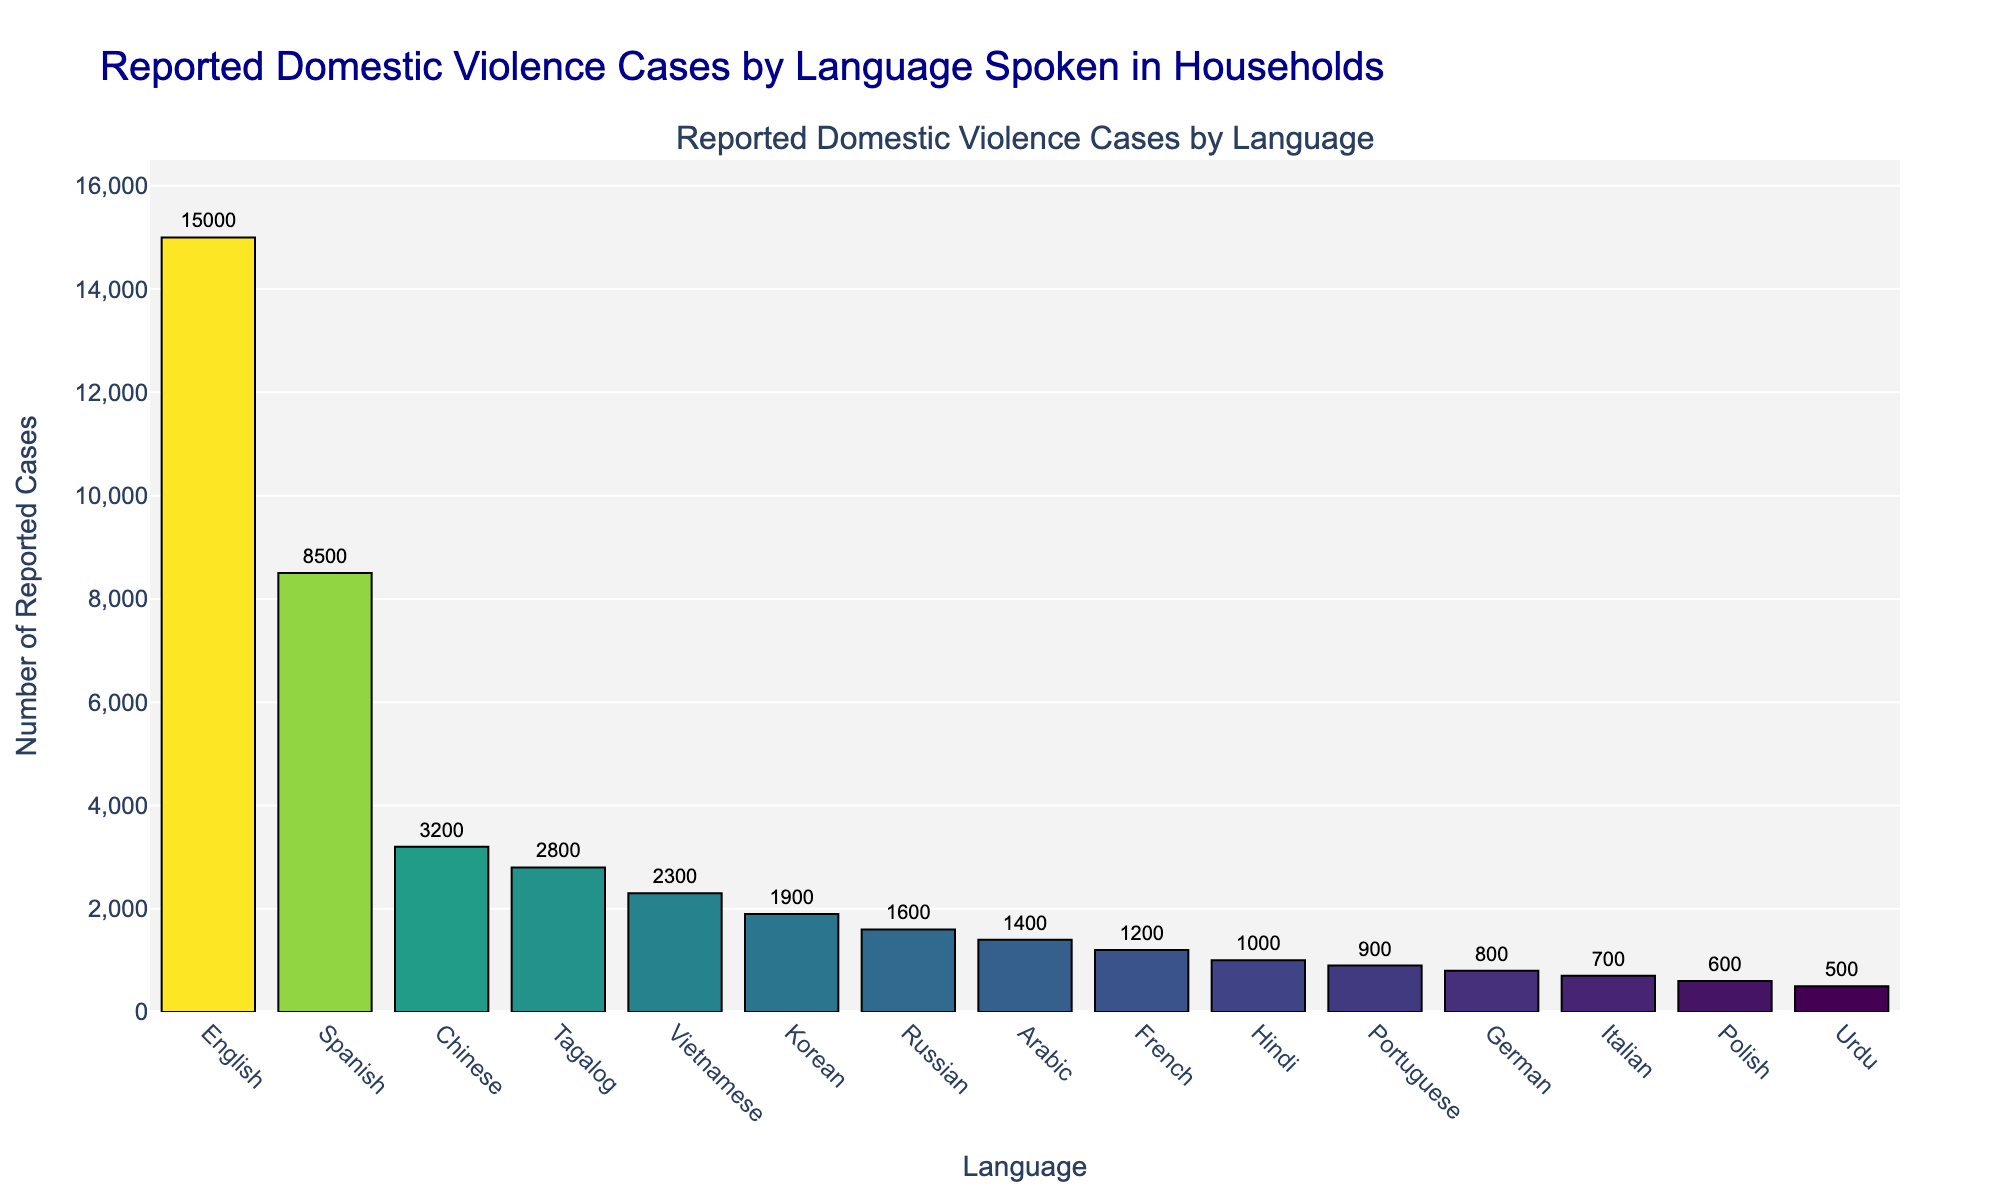Which language reported the highest number of domestic violence cases? The bar representing English is the tallest in the figure, indicating the highest number of reported cases.
Answer: English What is the difference in reported cases between the languages with the highest and lowest values? The highest number of reported cases is for English (15,000), and the lowest is for Urdu (500). The difference is 15,000 - 500 = 14,500.
Answer: 14,500 How many total reported cases are there for the top three languages combined? The top three languages are English (15,000), Spanish (8,500), and Chinese (3,200). The total is 15,000 + 8,500 + 3,200 = 26,700.
Answer: 26,700 Which language has more reported cases: Arabic or French? By comparing the bar lengths and numbers, Arabic has 1,400 reported cases whereas French has 1,200. Arabic has more reported cases.
Answer: Arabic What is the average number of reported cases for the languages listed? Summing all reported cases: 15,000 + 8,500 + 3,200 + 2,800 + 2,300 + 1,900 + 1,600 + 1,400 + 1,200 + 1,000 + 900 + 800 + 700 + 600 + 500 = 42,400. There are 15 languages. The average is 42,400 / 15 ≈ 2,827.
Answer: ~2,827 Which language reported the least number of domestic violence cases? The bar representing Urdu is the shortest in the figure, indicating the lowest number of reported cases.
Answer: Urdu Are there more reported cases for German and Italian combined than for Tagalog? German and Italian combined: 800 + 700 = 1,500. Tagalog has 2,800 cases. 1,500 is less than 2,800.
Answer: No What is the range of reported domestic violence cases among the languages? The highest value is 15,000 (English), and the lowest is 500 (Urdu). The range is 15,000 - 500 = 14,500.
Answer: 14,500 How does the number of reported cases for Vietnamese compare to that of Korean? Vietnamese has 2,300 reported cases, while Korean has 1,900. Vietnamese has more reported cases than Korean.
Answer: Vietnamese What is the combined total of reported cases for languages spoken less than 1,000 times? Counting languages with reported cases less than 1,000: Portuguese (900), German (800), Italian (700), Polish (600), Urdu (500). The total is 900 + 800 + 700 + 600 + 500 = 3,500.
Answer: 3,500 